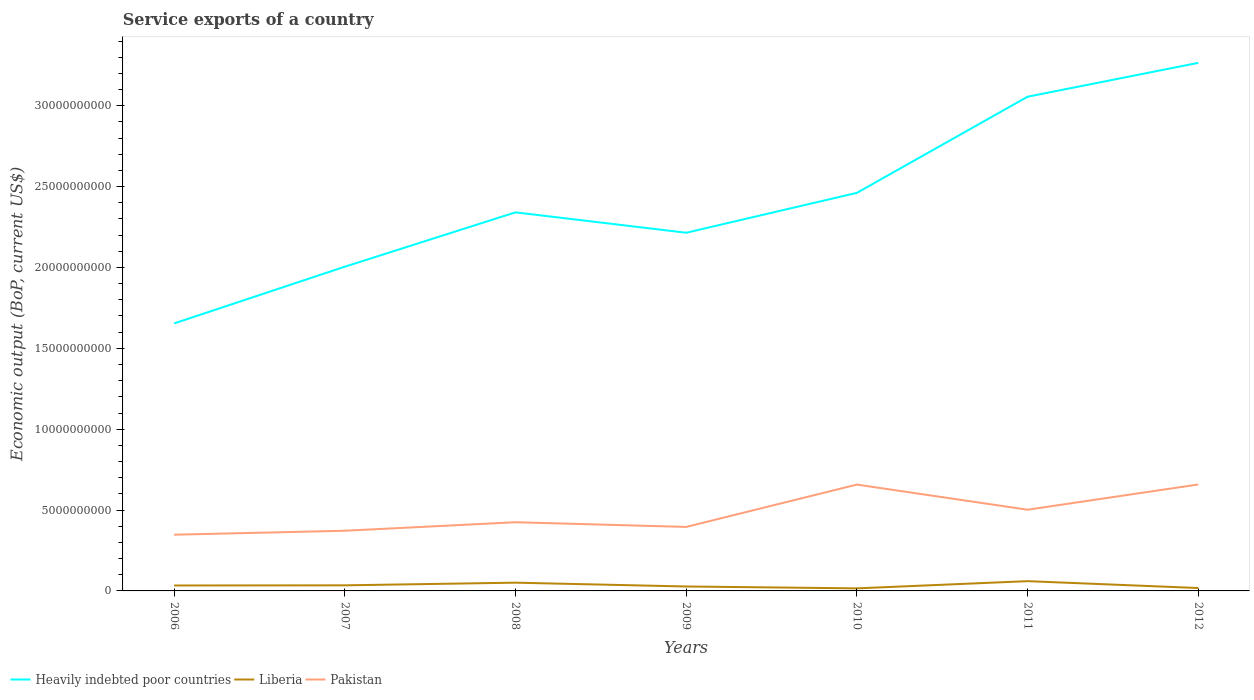How many different coloured lines are there?
Your answer should be very brief. 3. Is the number of lines equal to the number of legend labels?
Offer a terse response. Yes. Across all years, what is the maximum service exports in Heavily indebted poor countries?
Your answer should be very brief. 1.65e+1. What is the total service exports in Heavily indebted poor countries in the graph?
Your answer should be compact. -1.05e+1. What is the difference between the highest and the second highest service exports in Heavily indebted poor countries?
Give a very brief answer. 1.61e+1. Is the service exports in Pakistan strictly greater than the service exports in Heavily indebted poor countries over the years?
Your answer should be very brief. Yes. How many lines are there?
Provide a short and direct response. 3. Does the graph contain any zero values?
Ensure brevity in your answer.  No. How many legend labels are there?
Your answer should be very brief. 3. How are the legend labels stacked?
Give a very brief answer. Horizontal. What is the title of the graph?
Ensure brevity in your answer.  Service exports of a country. What is the label or title of the Y-axis?
Offer a very short reply. Economic output (BoP, current US$). What is the Economic output (BoP, current US$) of Heavily indebted poor countries in 2006?
Ensure brevity in your answer.  1.65e+1. What is the Economic output (BoP, current US$) of Liberia in 2006?
Make the answer very short. 3.36e+08. What is the Economic output (BoP, current US$) of Pakistan in 2006?
Offer a very short reply. 3.48e+09. What is the Economic output (BoP, current US$) in Heavily indebted poor countries in 2007?
Ensure brevity in your answer.  2.00e+1. What is the Economic output (BoP, current US$) of Liberia in 2007?
Give a very brief answer. 3.46e+08. What is the Economic output (BoP, current US$) of Pakistan in 2007?
Your answer should be compact. 3.72e+09. What is the Economic output (BoP, current US$) in Heavily indebted poor countries in 2008?
Keep it short and to the point. 2.34e+1. What is the Economic output (BoP, current US$) of Liberia in 2008?
Offer a very short reply. 5.10e+08. What is the Economic output (BoP, current US$) of Pakistan in 2008?
Your answer should be compact. 4.25e+09. What is the Economic output (BoP, current US$) in Heavily indebted poor countries in 2009?
Your answer should be compact. 2.21e+1. What is the Economic output (BoP, current US$) of Liberia in 2009?
Offer a very short reply. 2.74e+08. What is the Economic output (BoP, current US$) of Pakistan in 2009?
Keep it short and to the point. 3.96e+09. What is the Economic output (BoP, current US$) in Heavily indebted poor countries in 2010?
Keep it short and to the point. 2.46e+1. What is the Economic output (BoP, current US$) of Liberia in 2010?
Provide a succinct answer. 1.58e+08. What is the Economic output (BoP, current US$) of Pakistan in 2010?
Offer a terse response. 6.58e+09. What is the Economic output (BoP, current US$) of Heavily indebted poor countries in 2011?
Provide a short and direct response. 3.06e+1. What is the Economic output (BoP, current US$) in Liberia in 2011?
Ensure brevity in your answer.  6.04e+08. What is the Economic output (BoP, current US$) of Pakistan in 2011?
Ensure brevity in your answer.  5.02e+09. What is the Economic output (BoP, current US$) in Heavily indebted poor countries in 2012?
Provide a succinct answer. 3.27e+1. What is the Economic output (BoP, current US$) of Liberia in 2012?
Ensure brevity in your answer.  1.79e+08. What is the Economic output (BoP, current US$) of Pakistan in 2012?
Provide a succinct answer. 6.58e+09. Across all years, what is the maximum Economic output (BoP, current US$) in Heavily indebted poor countries?
Your answer should be compact. 3.27e+1. Across all years, what is the maximum Economic output (BoP, current US$) in Liberia?
Give a very brief answer. 6.04e+08. Across all years, what is the maximum Economic output (BoP, current US$) in Pakistan?
Your answer should be very brief. 6.58e+09. Across all years, what is the minimum Economic output (BoP, current US$) of Heavily indebted poor countries?
Make the answer very short. 1.65e+1. Across all years, what is the minimum Economic output (BoP, current US$) of Liberia?
Provide a succinct answer. 1.58e+08. Across all years, what is the minimum Economic output (BoP, current US$) of Pakistan?
Offer a very short reply. 3.48e+09. What is the total Economic output (BoP, current US$) of Heavily indebted poor countries in the graph?
Your response must be concise. 1.70e+11. What is the total Economic output (BoP, current US$) in Liberia in the graph?
Your answer should be compact. 2.41e+09. What is the total Economic output (BoP, current US$) of Pakistan in the graph?
Provide a short and direct response. 3.36e+1. What is the difference between the Economic output (BoP, current US$) of Heavily indebted poor countries in 2006 and that in 2007?
Give a very brief answer. -3.51e+09. What is the difference between the Economic output (BoP, current US$) of Liberia in 2006 and that in 2007?
Offer a very short reply. -9.68e+06. What is the difference between the Economic output (BoP, current US$) in Pakistan in 2006 and that in 2007?
Give a very brief answer. -2.45e+08. What is the difference between the Economic output (BoP, current US$) in Heavily indebted poor countries in 2006 and that in 2008?
Your answer should be very brief. -6.87e+09. What is the difference between the Economic output (BoP, current US$) of Liberia in 2006 and that in 2008?
Provide a succinct answer. -1.73e+08. What is the difference between the Economic output (BoP, current US$) of Pakistan in 2006 and that in 2008?
Give a very brief answer. -7.71e+08. What is the difference between the Economic output (BoP, current US$) in Heavily indebted poor countries in 2006 and that in 2009?
Your answer should be compact. -5.61e+09. What is the difference between the Economic output (BoP, current US$) in Liberia in 2006 and that in 2009?
Your answer should be compact. 6.24e+07. What is the difference between the Economic output (BoP, current US$) of Pakistan in 2006 and that in 2009?
Make the answer very short. -4.81e+08. What is the difference between the Economic output (BoP, current US$) in Heavily indebted poor countries in 2006 and that in 2010?
Provide a succinct answer. -8.07e+09. What is the difference between the Economic output (BoP, current US$) of Liberia in 2006 and that in 2010?
Offer a terse response. 1.79e+08. What is the difference between the Economic output (BoP, current US$) in Pakistan in 2006 and that in 2010?
Give a very brief answer. -3.10e+09. What is the difference between the Economic output (BoP, current US$) in Heavily indebted poor countries in 2006 and that in 2011?
Your response must be concise. -1.40e+1. What is the difference between the Economic output (BoP, current US$) of Liberia in 2006 and that in 2011?
Offer a very short reply. -2.68e+08. What is the difference between the Economic output (BoP, current US$) in Pakistan in 2006 and that in 2011?
Your answer should be compact. -1.55e+09. What is the difference between the Economic output (BoP, current US$) of Heavily indebted poor countries in 2006 and that in 2012?
Provide a short and direct response. -1.61e+1. What is the difference between the Economic output (BoP, current US$) of Liberia in 2006 and that in 2012?
Provide a succinct answer. 1.58e+08. What is the difference between the Economic output (BoP, current US$) of Pakistan in 2006 and that in 2012?
Ensure brevity in your answer.  -3.11e+09. What is the difference between the Economic output (BoP, current US$) of Heavily indebted poor countries in 2007 and that in 2008?
Offer a very short reply. -3.36e+09. What is the difference between the Economic output (BoP, current US$) in Liberia in 2007 and that in 2008?
Your answer should be compact. -1.63e+08. What is the difference between the Economic output (BoP, current US$) of Pakistan in 2007 and that in 2008?
Provide a succinct answer. -5.26e+08. What is the difference between the Economic output (BoP, current US$) in Heavily indebted poor countries in 2007 and that in 2009?
Offer a very short reply. -2.10e+09. What is the difference between the Economic output (BoP, current US$) of Liberia in 2007 and that in 2009?
Keep it short and to the point. 7.21e+07. What is the difference between the Economic output (BoP, current US$) in Pakistan in 2007 and that in 2009?
Make the answer very short. -2.36e+08. What is the difference between the Economic output (BoP, current US$) of Heavily indebted poor countries in 2007 and that in 2010?
Your response must be concise. -4.57e+09. What is the difference between the Economic output (BoP, current US$) in Liberia in 2007 and that in 2010?
Provide a short and direct response. 1.88e+08. What is the difference between the Economic output (BoP, current US$) in Pakistan in 2007 and that in 2010?
Provide a succinct answer. -2.85e+09. What is the difference between the Economic output (BoP, current US$) of Heavily indebted poor countries in 2007 and that in 2011?
Ensure brevity in your answer.  -1.05e+1. What is the difference between the Economic output (BoP, current US$) of Liberia in 2007 and that in 2011?
Keep it short and to the point. -2.58e+08. What is the difference between the Economic output (BoP, current US$) in Pakistan in 2007 and that in 2011?
Provide a succinct answer. -1.30e+09. What is the difference between the Economic output (BoP, current US$) in Heavily indebted poor countries in 2007 and that in 2012?
Your answer should be very brief. -1.26e+1. What is the difference between the Economic output (BoP, current US$) of Liberia in 2007 and that in 2012?
Give a very brief answer. 1.67e+08. What is the difference between the Economic output (BoP, current US$) of Pakistan in 2007 and that in 2012?
Ensure brevity in your answer.  -2.86e+09. What is the difference between the Economic output (BoP, current US$) of Heavily indebted poor countries in 2008 and that in 2009?
Your answer should be compact. 1.26e+09. What is the difference between the Economic output (BoP, current US$) of Liberia in 2008 and that in 2009?
Your response must be concise. 2.36e+08. What is the difference between the Economic output (BoP, current US$) of Pakistan in 2008 and that in 2009?
Your answer should be very brief. 2.90e+08. What is the difference between the Economic output (BoP, current US$) of Heavily indebted poor countries in 2008 and that in 2010?
Offer a terse response. -1.20e+09. What is the difference between the Economic output (BoP, current US$) in Liberia in 2008 and that in 2010?
Ensure brevity in your answer.  3.52e+08. What is the difference between the Economic output (BoP, current US$) in Pakistan in 2008 and that in 2010?
Your answer should be very brief. -2.33e+09. What is the difference between the Economic output (BoP, current US$) in Heavily indebted poor countries in 2008 and that in 2011?
Give a very brief answer. -7.15e+09. What is the difference between the Economic output (BoP, current US$) in Liberia in 2008 and that in 2011?
Keep it short and to the point. -9.45e+07. What is the difference between the Economic output (BoP, current US$) of Pakistan in 2008 and that in 2011?
Offer a terse response. -7.74e+08. What is the difference between the Economic output (BoP, current US$) in Heavily indebted poor countries in 2008 and that in 2012?
Your answer should be very brief. -9.24e+09. What is the difference between the Economic output (BoP, current US$) in Liberia in 2008 and that in 2012?
Ensure brevity in your answer.  3.31e+08. What is the difference between the Economic output (BoP, current US$) in Pakistan in 2008 and that in 2012?
Offer a very short reply. -2.33e+09. What is the difference between the Economic output (BoP, current US$) in Heavily indebted poor countries in 2009 and that in 2010?
Provide a short and direct response. -2.47e+09. What is the difference between the Economic output (BoP, current US$) of Liberia in 2009 and that in 2010?
Your response must be concise. 1.16e+08. What is the difference between the Economic output (BoP, current US$) in Pakistan in 2009 and that in 2010?
Ensure brevity in your answer.  -2.62e+09. What is the difference between the Economic output (BoP, current US$) of Heavily indebted poor countries in 2009 and that in 2011?
Give a very brief answer. -8.41e+09. What is the difference between the Economic output (BoP, current US$) of Liberia in 2009 and that in 2011?
Ensure brevity in your answer.  -3.30e+08. What is the difference between the Economic output (BoP, current US$) in Pakistan in 2009 and that in 2011?
Keep it short and to the point. -1.06e+09. What is the difference between the Economic output (BoP, current US$) in Heavily indebted poor countries in 2009 and that in 2012?
Make the answer very short. -1.05e+1. What is the difference between the Economic output (BoP, current US$) of Liberia in 2009 and that in 2012?
Offer a very short reply. 9.52e+07. What is the difference between the Economic output (BoP, current US$) in Pakistan in 2009 and that in 2012?
Provide a succinct answer. -2.62e+09. What is the difference between the Economic output (BoP, current US$) of Heavily indebted poor countries in 2010 and that in 2011?
Your answer should be very brief. -5.94e+09. What is the difference between the Economic output (BoP, current US$) in Liberia in 2010 and that in 2011?
Offer a terse response. -4.46e+08. What is the difference between the Economic output (BoP, current US$) of Pakistan in 2010 and that in 2011?
Provide a succinct answer. 1.55e+09. What is the difference between the Economic output (BoP, current US$) in Heavily indebted poor countries in 2010 and that in 2012?
Your response must be concise. -8.04e+09. What is the difference between the Economic output (BoP, current US$) of Liberia in 2010 and that in 2012?
Provide a short and direct response. -2.09e+07. What is the difference between the Economic output (BoP, current US$) in Pakistan in 2010 and that in 2012?
Provide a short and direct response. -6.20e+06. What is the difference between the Economic output (BoP, current US$) in Heavily indebted poor countries in 2011 and that in 2012?
Your answer should be compact. -2.09e+09. What is the difference between the Economic output (BoP, current US$) in Liberia in 2011 and that in 2012?
Provide a succinct answer. 4.25e+08. What is the difference between the Economic output (BoP, current US$) in Pakistan in 2011 and that in 2012?
Your answer should be very brief. -1.56e+09. What is the difference between the Economic output (BoP, current US$) of Heavily indebted poor countries in 2006 and the Economic output (BoP, current US$) of Liberia in 2007?
Keep it short and to the point. 1.62e+1. What is the difference between the Economic output (BoP, current US$) of Heavily indebted poor countries in 2006 and the Economic output (BoP, current US$) of Pakistan in 2007?
Your answer should be very brief. 1.28e+1. What is the difference between the Economic output (BoP, current US$) of Liberia in 2006 and the Economic output (BoP, current US$) of Pakistan in 2007?
Ensure brevity in your answer.  -3.38e+09. What is the difference between the Economic output (BoP, current US$) in Heavily indebted poor countries in 2006 and the Economic output (BoP, current US$) in Liberia in 2008?
Provide a succinct answer. 1.60e+1. What is the difference between the Economic output (BoP, current US$) in Heavily indebted poor countries in 2006 and the Economic output (BoP, current US$) in Pakistan in 2008?
Keep it short and to the point. 1.23e+1. What is the difference between the Economic output (BoP, current US$) of Liberia in 2006 and the Economic output (BoP, current US$) of Pakistan in 2008?
Provide a short and direct response. -3.91e+09. What is the difference between the Economic output (BoP, current US$) of Heavily indebted poor countries in 2006 and the Economic output (BoP, current US$) of Liberia in 2009?
Provide a short and direct response. 1.63e+1. What is the difference between the Economic output (BoP, current US$) in Heavily indebted poor countries in 2006 and the Economic output (BoP, current US$) in Pakistan in 2009?
Provide a short and direct response. 1.26e+1. What is the difference between the Economic output (BoP, current US$) of Liberia in 2006 and the Economic output (BoP, current US$) of Pakistan in 2009?
Keep it short and to the point. -3.62e+09. What is the difference between the Economic output (BoP, current US$) of Heavily indebted poor countries in 2006 and the Economic output (BoP, current US$) of Liberia in 2010?
Your answer should be compact. 1.64e+1. What is the difference between the Economic output (BoP, current US$) in Heavily indebted poor countries in 2006 and the Economic output (BoP, current US$) in Pakistan in 2010?
Ensure brevity in your answer.  9.96e+09. What is the difference between the Economic output (BoP, current US$) of Liberia in 2006 and the Economic output (BoP, current US$) of Pakistan in 2010?
Keep it short and to the point. -6.24e+09. What is the difference between the Economic output (BoP, current US$) in Heavily indebted poor countries in 2006 and the Economic output (BoP, current US$) in Liberia in 2011?
Give a very brief answer. 1.59e+1. What is the difference between the Economic output (BoP, current US$) in Heavily indebted poor countries in 2006 and the Economic output (BoP, current US$) in Pakistan in 2011?
Ensure brevity in your answer.  1.15e+1. What is the difference between the Economic output (BoP, current US$) in Liberia in 2006 and the Economic output (BoP, current US$) in Pakistan in 2011?
Provide a short and direct response. -4.68e+09. What is the difference between the Economic output (BoP, current US$) of Heavily indebted poor countries in 2006 and the Economic output (BoP, current US$) of Liberia in 2012?
Provide a succinct answer. 1.64e+1. What is the difference between the Economic output (BoP, current US$) of Heavily indebted poor countries in 2006 and the Economic output (BoP, current US$) of Pakistan in 2012?
Your answer should be very brief. 9.96e+09. What is the difference between the Economic output (BoP, current US$) of Liberia in 2006 and the Economic output (BoP, current US$) of Pakistan in 2012?
Make the answer very short. -6.24e+09. What is the difference between the Economic output (BoP, current US$) in Heavily indebted poor countries in 2007 and the Economic output (BoP, current US$) in Liberia in 2008?
Your answer should be compact. 1.95e+1. What is the difference between the Economic output (BoP, current US$) in Heavily indebted poor countries in 2007 and the Economic output (BoP, current US$) in Pakistan in 2008?
Make the answer very short. 1.58e+1. What is the difference between the Economic output (BoP, current US$) in Liberia in 2007 and the Economic output (BoP, current US$) in Pakistan in 2008?
Offer a terse response. -3.90e+09. What is the difference between the Economic output (BoP, current US$) of Heavily indebted poor countries in 2007 and the Economic output (BoP, current US$) of Liberia in 2009?
Offer a very short reply. 1.98e+1. What is the difference between the Economic output (BoP, current US$) of Heavily indebted poor countries in 2007 and the Economic output (BoP, current US$) of Pakistan in 2009?
Make the answer very short. 1.61e+1. What is the difference between the Economic output (BoP, current US$) of Liberia in 2007 and the Economic output (BoP, current US$) of Pakistan in 2009?
Offer a terse response. -3.61e+09. What is the difference between the Economic output (BoP, current US$) of Heavily indebted poor countries in 2007 and the Economic output (BoP, current US$) of Liberia in 2010?
Offer a terse response. 1.99e+1. What is the difference between the Economic output (BoP, current US$) in Heavily indebted poor countries in 2007 and the Economic output (BoP, current US$) in Pakistan in 2010?
Provide a succinct answer. 1.35e+1. What is the difference between the Economic output (BoP, current US$) of Liberia in 2007 and the Economic output (BoP, current US$) of Pakistan in 2010?
Keep it short and to the point. -6.23e+09. What is the difference between the Economic output (BoP, current US$) in Heavily indebted poor countries in 2007 and the Economic output (BoP, current US$) in Liberia in 2011?
Provide a succinct answer. 1.94e+1. What is the difference between the Economic output (BoP, current US$) in Heavily indebted poor countries in 2007 and the Economic output (BoP, current US$) in Pakistan in 2011?
Make the answer very short. 1.50e+1. What is the difference between the Economic output (BoP, current US$) in Liberia in 2007 and the Economic output (BoP, current US$) in Pakistan in 2011?
Provide a succinct answer. -4.67e+09. What is the difference between the Economic output (BoP, current US$) in Heavily indebted poor countries in 2007 and the Economic output (BoP, current US$) in Liberia in 2012?
Make the answer very short. 1.99e+1. What is the difference between the Economic output (BoP, current US$) of Heavily indebted poor countries in 2007 and the Economic output (BoP, current US$) of Pakistan in 2012?
Provide a short and direct response. 1.35e+1. What is the difference between the Economic output (BoP, current US$) of Liberia in 2007 and the Economic output (BoP, current US$) of Pakistan in 2012?
Your answer should be compact. -6.24e+09. What is the difference between the Economic output (BoP, current US$) of Heavily indebted poor countries in 2008 and the Economic output (BoP, current US$) of Liberia in 2009?
Keep it short and to the point. 2.31e+1. What is the difference between the Economic output (BoP, current US$) in Heavily indebted poor countries in 2008 and the Economic output (BoP, current US$) in Pakistan in 2009?
Keep it short and to the point. 1.95e+1. What is the difference between the Economic output (BoP, current US$) of Liberia in 2008 and the Economic output (BoP, current US$) of Pakistan in 2009?
Offer a very short reply. -3.45e+09. What is the difference between the Economic output (BoP, current US$) of Heavily indebted poor countries in 2008 and the Economic output (BoP, current US$) of Liberia in 2010?
Your answer should be very brief. 2.32e+1. What is the difference between the Economic output (BoP, current US$) in Heavily indebted poor countries in 2008 and the Economic output (BoP, current US$) in Pakistan in 2010?
Make the answer very short. 1.68e+1. What is the difference between the Economic output (BoP, current US$) in Liberia in 2008 and the Economic output (BoP, current US$) in Pakistan in 2010?
Make the answer very short. -6.07e+09. What is the difference between the Economic output (BoP, current US$) in Heavily indebted poor countries in 2008 and the Economic output (BoP, current US$) in Liberia in 2011?
Provide a short and direct response. 2.28e+1. What is the difference between the Economic output (BoP, current US$) in Heavily indebted poor countries in 2008 and the Economic output (BoP, current US$) in Pakistan in 2011?
Provide a short and direct response. 1.84e+1. What is the difference between the Economic output (BoP, current US$) in Liberia in 2008 and the Economic output (BoP, current US$) in Pakistan in 2011?
Provide a short and direct response. -4.51e+09. What is the difference between the Economic output (BoP, current US$) of Heavily indebted poor countries in 2008 and the Economic output (BoP, current US$) of Liberia in 2012?
Your response must be concise. 2.32e+1. What is the difference between the Economic output (BoP, current US$) of Heavily indebted poor countries in 2008 and the Economic output (BoP, current US$) of Pakistan in 2012?
Offer a very short reply. 1.68e+1. What is the difference between the Economic output (BoP, current US$) in Liberia in 2008 and the Economic output (BoP, current US$) in Pakistan in 2012?
Your response must be concise. -6.07e+09. What is the difference between the Economic output (BoP, current US$) of Heavily indebted poor countries in 2009 and the Economic output (BoP, current US$) of Liberia in 2010?
Provide a short and direct response. 2.20e+1. What is the difference between the Economic output (BoP, current US$) of Heavily indebted poor countries in 2009 and the Economic output (BoP, current US$) of Pakistan in 2010?
Ensure brevity in your answer.  1.56e+1. What is the difference between the Economic output (BoP, current US$) of Liberia in 2009 and the Economic output (BoP, current US$) of Pakistan in 2010?
Offer a very short reply. -6.30e+09. What is the difference between the Economic output (BoP, current US$) in Heavily indebted poor countries in 2009 and the Economic output (BoP, current US$) in Liberia in 2011?
Ensure brevity in your answer.  2.15e+1. What is the difference between the Economic output (BoP, current US$) of Heavily indebted poor countries in 2009 and the Economic output (BoP, current US$) of Pakistan in 2011?
Your answer should be very brief. 1.71e+1. What is the difference between the Economic output (BoP, current US$) in Liberia in 2009 and the Economic output (BoP, current US$) in Pakistan in 2011?
Offer a very short reply. -4.75e+09. What is the difference between the Economic output (BoP, current US$) of Heavily indebted poor countries in 2009 and the Economic output (BoP, current US$) of Liberia in 2012?
Your answer should be compact. 2.20e+1. What is the difference between the Economic output (BoP, current US$) in Heavily indebted poor countries in 2009 and the Economic output (BoP, current US$) in Pakistan in 2012?
Provide a succinct answer. 1.56e+1. What is the difference between the Economic output (BoP, current US$) of Liberia in 2009 and the Economic output (BoP, current US$) of Pakistan in 2012?
Make the answer very short. -6.31e+09. What is the difference between the Economic output (BoP, current US$) in Heavily indebted poor countries in 2010 and the Economic output (BoP, current US$) in Liberia in 2011?
Keep it short and to the point. 2.40e+1. What is the difference between the Economic output (BoP, current US$) of Heavily indebted poor countries in 2010 and the Economic output (BoP, current US$) of Pakistan in 2011?
Provide a short and direct response. 1.96e+1. What is the difference between the Economic output (BoP, current US$) in Liberia in 2010 and the Economic output (BoP, current US$) in Pakistan in 2011?
Your response must be concise. -4.86e+09. What is the difference between the Economic output (BoP, current US$) of Heavily indebted poor countries in 2010 and the Economic output (BoP, current US$) of Liberia in 2012?
Your answer should be very brief. 2.44e+1. What is the difference between the Economic output (BoP, current US$) of Heavily indebted poor countries in 2010 and the Economic output (BoP, current US$) of Pakistan in 2012?
Offer a very short reply. 1.80e+1. What is the difference between the Economic output (BoP, current US$) of Liberia in 2010 and the Economic output (BoP, current US$) of Pakistan in 2012?
Provide a succinct answer. -6.42e+09. What is the difference between the Economic output (BoP, current US$) of Heavily indebted poor countries in 2011 and the Economic output (BoP, current US$) of Liberia in 2012?
Provide a succinct answer. 3.04e+1. What is the difference between the Economic output (BoP, current US$) of Heavily indebted poor countries in 2011 and the Economic output (BoP, current US$) of Pakistan in 2012?
Provide a short and direct response. 2.40e+1. What is the difference between the Economic output (BoP, current US$) in Liberia in 2011 and the Economic output (BoP, current US$) in Pakistan in 2012?
Make the answer very short. -5.98e+09. What is the average Economic output (BoP, current US$) in Heavily indebted poor countries per year?
Your answer should be compact. 2.43e+1. What is the average Economic output (BoP, current US$) in Liberia per year?
Offer a terse response. 3.44e+08. What is the average Economic output (BoP, current US$) in Pakistan per year?
Offer a terse response. 4.80e+09. In the year 2006, what is the difference between the Economic output (BoP, current US$) of Heavily indebted poor countries and Economic output (BoP, current US$) of Liberia?
Your response must be concise. 1.62e+1. In the year 2006, what is the difference between the Economic output (BoP, current US$) in Heavily indebted poor countries and Economic output (BoP, current US$) in Pakistan?
Offer a terse response. 1.31e+1. In the year 2006, what is the difference between the Economic output (BoP, current US$) in Liberia and Economic output (BoP, current US$) in Pakistan?
Your response must be concise. -3.14e+09. In the year 2007, what is the difference between the Economic output (BoP, current US$) of Heavily indebted poor countries and Economic output (BoP, current US$) of Liberia?
Give a very brief answer. 1.97e+1. In the year 2007, what is the difference between the Economic output (BoP, current US$) of Heavily indebted poor countries and Economic output (BoP, current US$) of Pakistan?
Provide a succinct answer. 1.63e+1. In the year 2007, what is the difference between the Economic output (BoP, current US$) in Liberia and Economic output (BoP, current US$) in Pakistan?
Make the answer very short. -3.37e+09. In the year 2008, what is the difference between the Economic output (BoP, current US$) of Heavily indebted poor countries and Economic output (BoP, current US$) of Liberia?
Offer a terse response. 2.29e+1. In the year 2008, what is the difference between the Economic output (BoP, current US$) in Heavily indebted poor countries and Economic output (BoP, current US$) in Pakistan?
Your response must be concise. 1.92e+1. In the year 2008, what is the difference between the Economic output (BoP, current US$) of Liberia and Economic output (BoP, current US$) of Pakistan?
Provide a succinct answer. -3.74e+09. In the year 2009, what is the difference between the Economic output (BoP, current US$) of Heavily indebted poor countries and Economic output (BoP, current US$) of Liberia?
Keep it short and to the point. 2.19e+1. In the year 2009, what is the difference between the Economic output (BoP, current US$) of Heavily indebted poor countries and Economic output (BoP, current US$) of Pakistan?
Your response must be concise. 1.82e+1. In the year 2009, what is the difference between the Economic output (BoP, current US$) in Liberia and Economic output (BoP, current US$) in Pakistan?
Your answer should be very brief. -3.68e+09. In the year 2010, what is the difference between the Economic output (BoP, current US$) in Heavily indebted poor countries and Economic output (BoP, current US$) in Liberia?
Give a very brief answer. 2.45e+1. In the year 2010, what is the difference between the Economic output (BoP, current US$) of Heavily indebted poor countries and Economic output (BoP, current US$) of Pakistan?
Keep it short and to the point. 1.80e+1. In the year 2010, what is the difference between the Economic output (BoP, current US$) in Liberia and Economic output (BoP, current US$) in Pakistan?
Keep it short and to the point. -6.42e+09. In the year 2011, what is the difference between the Economic output (BoP, current US$) of Heavily indebted poor countries and Economic output (BoP, current US$) of Liberia?
Keep it short and to the point. 3.00e+1. In the year 2011, what is the difference between the Economic output (BoP, current US$) in Heavily indebted poor countries and Economic output (BoP, current US$) in Pakistan?
Your answer should be compact. 2.55e+1. In the year 2011, what is the difference between the Economic output (BoP, current US$) of Liberia and Economic output (BoP, current US$) of Pakistan?
Offer a terse response. -4.42e+09. In the year 2012, what is the difference between the Economic output (BoP, current US$) of Heavily indebted poor countries and Economic output (BoP, current US$) of Liberia?
Offer a terse response. 3.25e+1. In the year 2012, what is the difference between the Economic output (BoP, current US$) in Heavily indebted poor countries and Economic output (BoP, current US$) in Pakistan?
Your answer should be compact. 2.61e+1. In the year 2012, what is the difference between the Economic output (BoP, current US$) of Liberia and Economic output (BoP, current US$) of Pakistan?
Your response must be concise. -6.40e+09. What is the ratio of the Economic output (BoP, current US$) in Heavily indebted poor countries in 2006 to that in 2007?
Offer a terse response. 0.83. What is the ratio of the Economic output (BoP, current US$) of Liberia in 2006 to that in 2007?
Give a very brief answer. 0.97. What is the ratio of the Economic output (BoP, current US$) of Pakistan in 2006 to that in 2007?
Provide a short and direct response. 0.93. What is the ratio of the Economic output (BoP, current US$) in Heavily indebted poor countries in 2006 to that in 2008?
Your response must be concise. 0.71. What is the ratio of the Economic output (BoP, current US$) of Liberia in 2006 to that in 2008?
Offer a very short reply. 0.66. What is the ratio of the Economic output (BoP, current US$) of Pakistan in 2006 to that in 2008?
Provide a succinct answer. 0.82. What is the ratio of the Economic output (BoP, current US$) of Heavily indebted poor countries in 2006 to that in 2009?
Keep it short and to the point. 0.75. What is the ratio of the Economic output (BoP, current US$) in Liberia in 2006 to that in 2009?
Your response must be concise. 1.23. What is the ratio of the Economic output (BoP, current US$) of Pakistan in 2006 to that in 2009?
Ensure brevity in your answer.  0.88. What is the ratio of the Economic output (BoP, current US$) of Heavily indebted poor countries in 2006 to that in 2010?
Keep it short and to the point. 0.67. What is the ratio of the Economic output (BoP, current US$) in Liberia in 2006 to that in 2010?
Keep it short and to the point. 2.13. What is the ratio of the Economic output (BoP, current US$) in Pakistan in 2006 to that in 2010?
Your answer should be very brief. 0.53. What is the ratio of the Economic output (BoP, current US$) of Heavily indebted poor countries in 2006 to that in 2011?
Make the answer very short. 0.54. What is the ratio of the Economic output (BoP, current US$) in Liberia in 2006 to that in 2011?
Give a very brief answer. 0.56. What is the ratio of the Economic output (BoP, current US$) in Pakistan in 2006 to that in 2011?
Provide a short and direct response. 0.69. What is the ratio of the Economic output (BoP, current US$) in Heavily indebted poor countries in 2006 to that in 2012?
Ensure brevity in your answer.  0.51. What is the ratio of the Economic output (BoP, current US$) in Liberia in 2006 to that in 2012?
Make the answer very short. 1.88. What is the ratio of the Economic output (BoP, current US$) in Pakistan in 2006 to that in 2012?
Give a very brief answer. 0.53. What is the ratio of the Economic output (BoP, current US$) of Heavily indebted poor countries in 2007 to that in 2008?
Give a very brief answer. 0.86. What is the ratio of the Economic output (BoP, current US$) of Liberia in 2007 to that in 2008?
Provide a succinct answer. 0.68. What is the ratio of the Economic output (BoP, current US$) of Pakistan in 2007 to that in 2008?
Give a very brief answer. 0.88. What is the ratio of the Economic output (BoP, current US$) of Heavily indebted poor countries in 2007 to that in 2009?
Give a very brief answer. 0.91. What is the ratio of the Economic output (BoP, current US$) in Liberia in 2007 to that in 2009?
Offer a terse response. 1.26. What is the ratio of the Economic output (BoP, current US$) in Pakistan in 2007 to that in 2009?
Your answer should be compact. 0.94. What is the ratio of the Economic output (BoP, current US$) of Heavily indebted poor countries in 2007 to that in 2010?
Your answer should be compact. 0.81. What is the ratio of the Economic output (BoP, current US$) of Liberia in 2007 to that in 2010?
Offer a terse response. 2.19. What is the ratio of the Economic output (BoP, current US$) of Pakistan in 2007 to that in 2010?
Your response must be concise. 0.57. What is the ratio of the Economic output (BoP, current US$) in Heavily indebted poor countries in 2007 to that in 2011?
Offer a very short reply. 0.66. What is the ratio of the Economic output (BoP, current US$) in Liberia in 2007 to that in 2011?
Keep it short and to the point. 0.57. What is the ratio of the Economic output (BoP, current US$) of Pakistan in 2007 to that in 2011?
Offer a terse response. 0.74. What is the ratio of the Economic output (BoP, current US$) of Heavily indebted poor countries in 2007 to that in 2012?
Provide a succinct answer. 0.61. What is the ratio of the Economic output (BoP, current US$) in Liberia in 2007 to that in 2012?
Give a very brief answer. 1.94. What is the ratio of the Economic output (BoP, current US$) of Pakistan in 2007 to that in 2012?
Give a very brief answer. 0.57. What is the ratio of the Economic output (BoP, current US$) in Heavily indebted poor countries in 2008 to that in 2009?
Give a very brief answer. 1.06. What is the ratio of the Economic output (BoP, current US$) of Liberia in 2008 to that in 2009?
Make the answer very short. 1.86. What is the ratio of the Economic output (BoP, current US$) in Pakistan in 2008 to that in 2009?
Offer a very short reply. 1.07. What is the ratio of the Economic output (BoP, current US$) of Heavily indebted poor countries in 2008 to that in 2010?
Your response must be concise. 0.95. What is the ratio of the Economic output (BoP, current US$) of Liberia in 2008 to that in 2010?
Give a very brief answer. 3.23. What is the ratio of the Economic output (BoP, current US$) of Pakistan in 2008 to that in 2010?
Your answer should be very brief. 0.65. What is the ratio of the Economic output (BoP, current US$) in Heavily indebted poor countries in 2008 to that in 2011?
Ensure brevity in your answer.  0.77. What is the ratio of the Economic output (BoP, current US$) in Liberia in 2008 to that in 2011?
Ensure brevity in your answer.  0.84. What is the ratio of the Economic output (BoP, current US$) of Pakistan in 2008 to that in 2011?
Ensure brevity in your answer.  0.85. What is the ratio of the Economic output (BoP, current US$) in Heavily indebted poor countries in 2008 to that in 2012?
Provide a succinct answer. 0.72. What is the ratio of the Economic output (BoP, current US$) of Liberia in 2008 to that in 2012?
Your answer should be very brief. 2.85. What is the ratio of the Economic output (BoP, current US$) in Pakistan in 2008 to that in 2012?
Offer a very short reply. 0.65. What is the ratio of the Economic output (BoP, current US$) of Heavily indebted poor countries in 2009 to that in 2010?
Keep it short and to the point. 0.9. What is the ratio of the Economic output (BoP, current US$) of Liberia in 2009 to that in 2010?
Provide a succinct answer. 1.73. What is the ratio of the Economic output (BoP, current US$) of Pakistan in 2009 to that in 2010?
Keep it short and to the point. 0.6. What is the ratio of the Economic output (BoP, current US$) of Heavily indebted poor countries in 2009 to that in 2011?
Make the answer very short. 0.72. What is the ratio of the Economic output (BoP, current US$) of Liberia in 2009 to that in 2011?
Ensure brevity in your answer.  0.45. What is the ratio of the Economic output (BoP, current US$) in Pakistan in 2009 to that in 2011?
Offer a terse response. 0.79. What is the ratio of the Economic output (BoP, current US$) of Heavily indebted poor countries in 2009 to that in 2012?
Offer a very short reply. 0.68. What is the ratio of the Economic output (BoP, current US$) of Liberia in 2009 to that in 2012?
Offer a very short reply. 1.53. What is the ratio of the Economic output (BoP, current US$) in Pakistan in 2009 to that in 2012?
Keep it short and to the point. 0.6. What is the ratio of the Economic output (BoP, current US$) of Heavily indebted poor countries in 2010 to that in 2011?
Keep it short and to the point. 0.81. What is the ratio of the Economic output (BoP, current US$) in Liberia in 2010 to that in 2011?
Your response must be concise. 0.26. What is the ratio of the Economic output (BoP, current US$) in Pakistan in 2010 to that in 2011?
Your answer should be very brief. 1.31. What is the ratio of the Economic output (BoP, current US$) of Heavily indebted poor countries in 2010 to that in 2012?
Your answer should be very brief. 0.75. What is the ratio of the Economic output (BoP, current US$) in Liberia in 2010 to that in 2012?
Ensure brevity in your answer.  0.88. What is the ratio of the Economic output (BoP, current US$) of Pakistan in 2010 to that in 2012?
Provide a succinct answer. 1. What is the ratio of the Economic output (BoP, current US$) in Heavily indebted poor countries in 2011 to that in 2012?
Keep it short and to the point. 0.94. What is the ratio of the Economic output (BoP, current US$) of Liberia in 2011 to that in 2012?
Ensure brevity in your answer.  3.38. What is the ratio of the Economic output (BoP, current US$) in Pakistan in 2011 to that in 2012?
Ensure brevity in your answer.  0.76. What is the difference between the highest and the second highest Economic output (BoP, current US$) in Heavily indebted poor countries?
Keep it short and to the point. 2.09e+09. What is the difference between the highest and the second highest Economic output (BoP, current US$) in Liberia?
Offer a terse response. 9.45e+07. What is the difference between the highest and the second highest Economic output (BoP, current US$) in Pakistan?
Provide a succinct answer. 6.20e+06. What is the difference between the highest and the lowest Economic output (BoP, current US$) in Heavily indebted poor countries?
Keep it short and to the point. 1.61e+1. What is the difference between the highest and the lowest Economic output (BoP, current US$) of Liberia?
Offer a terse response. 4.46e+08. What is the difference between the highest and the lowest Economic output (BoP, current US$) in Pakistan?
Your answer should be very brief. 3.11e+09. 